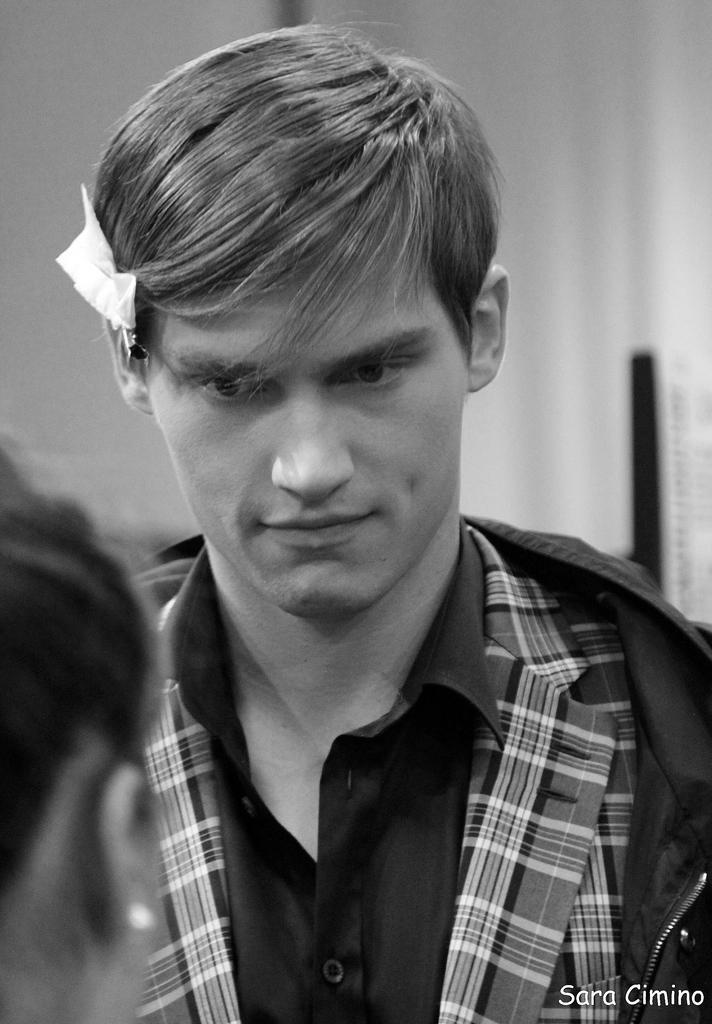Can you describe this image briefly? This is a black and white picture. Background portion of the picture is blur. In this picture we can see a person. On the left side of the picture we can see the partial part of a person's head and we can see an ear of a same person. In the bottom right corner of the picture can see watermark. 